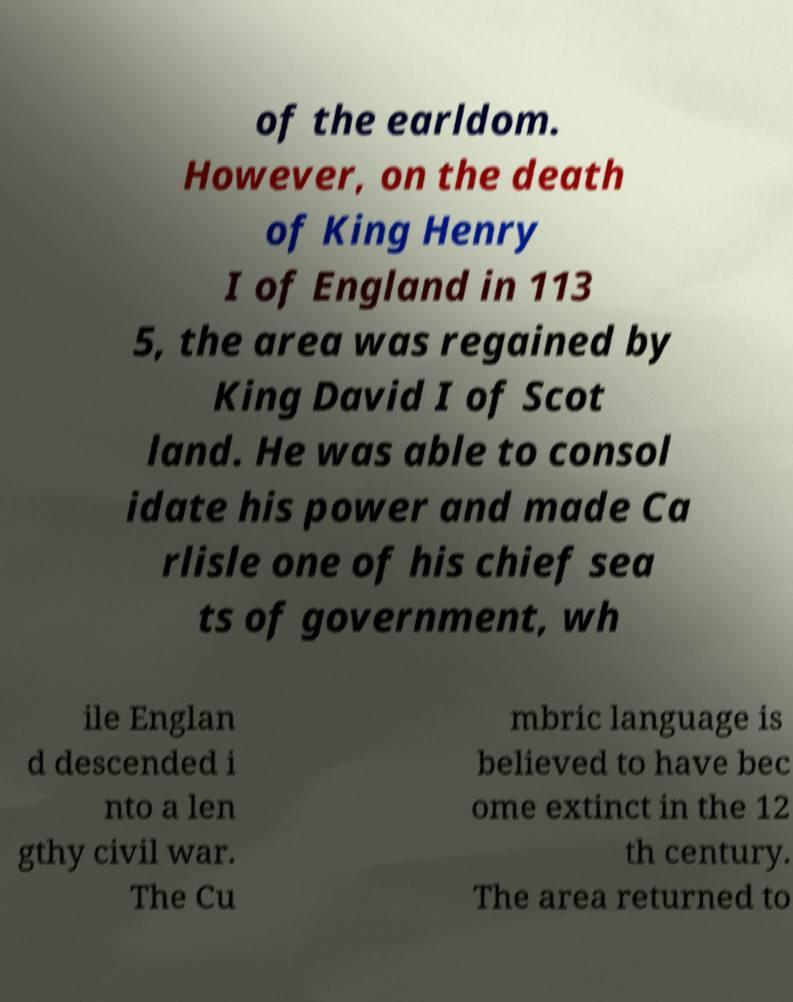For documentation purposes, I need the text within this image transcribed. Could you provide that? of the earldom. However, on the death of King Henry I of England in 113 5, the area was regained by King David I of Scot land. He was able to consol idate his power and made Ca rlisle one of his chief sea ts of government, wh ile Englan d descended i nto a len gthy civil war. The Cu mbric language is believed to have bec ome extinct in the 12 th century. The area returned to 